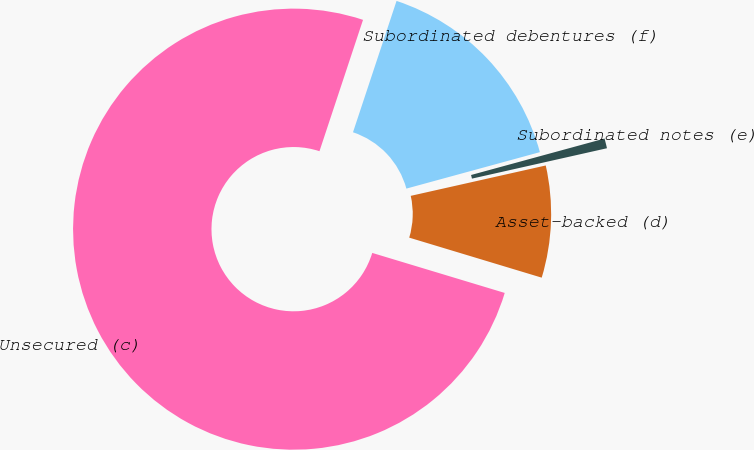Convert chart. <chart><loc_0><loc_0><loc_500><loc_500><pie_chart><fcel>Unsecured (c)<fcel>Asset-backed (d)<fcel>Subordinated notes (e)<fcel>Subordinated debentures (f)<nl><fcel>75.42%<fcel>8.19%<fcel>0.72%<fcel>15.66%<nl></chart> 